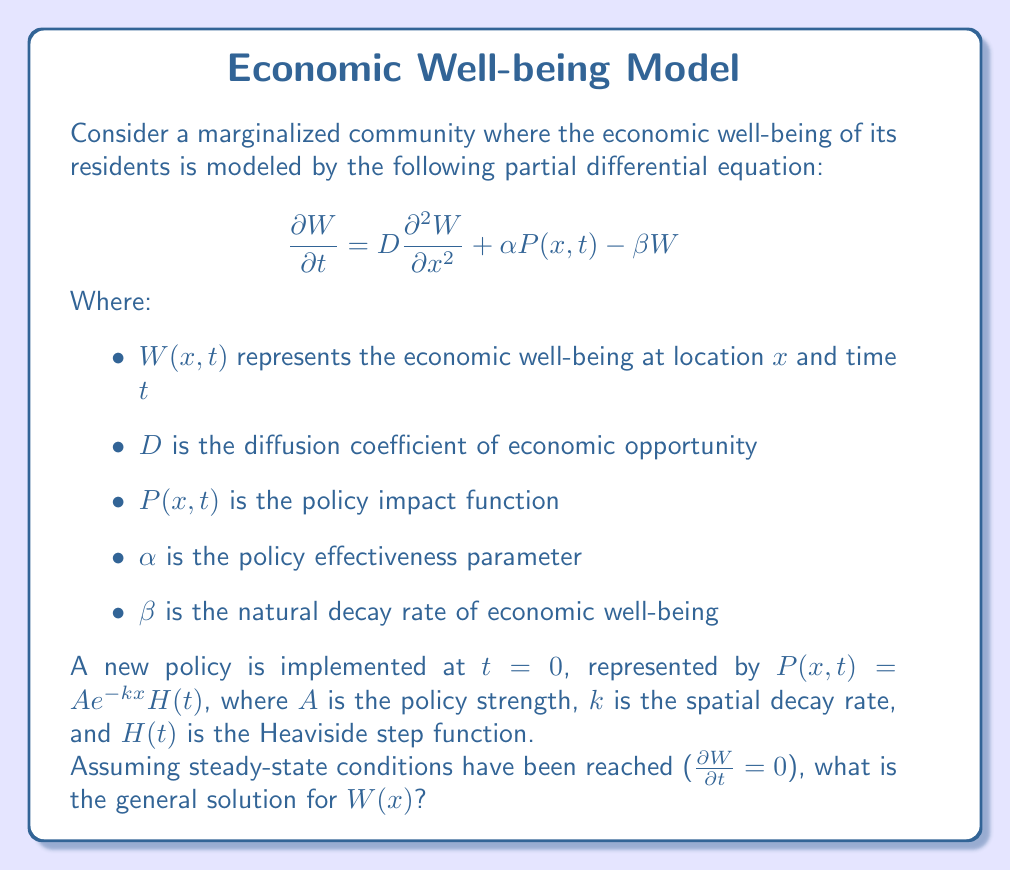Solve this math problem. To solve this problem, we'll follow these steps:

1) First, we recognize that at steady-state, $\frac{\partial W}{\partial t} = 0$. This simplifies our PDE to an ODE:

   $$D\frac{d^2 W}{dx^2} + \alpha P(x) - \beta W = 0$$

2) Substituting the given policy function $P(x) = Ae^{-kx}$, we get:

   $$D\frac{d^2 W}{dx^2} + \alpha Ae^{-kx} - \beta W = 0$$

3) This is a non-homogeneous second-order ODE. The general solution will be the sum of the homogeneous solution $W_h(x)$ and a particular solution $W_p(x)$.

4) For the homogeneous part, we solve:

   $$D\frac{d^2 W_h}{dx^2} - \beta W_h = 0$$

   The characteristic equation is $Dr^2 - \beta = 0$, giving $r = \pm \sqrt{\frac{\beta}{D}}$.

   Therefore, $W_h(x) = C_1e^{\sqrt{\frac{\beta}{D}}x} + C_2e^{-\sqrt{\frac{\beta}{D}}x}$

5) For the particular solution, we guess a form $W_p(x) = Be^{-kx}$, where $B$ is a constant to be determined.

6) Substituting this into the original ODE:

   $$D(-k)^2Be^{-kx} + \alpha Ae^{-kx} - \beta Be^{-kx} = 0$$

   $$(Dk^2 - \beta)Be^{-kx} + \alpha Ae^{-kx} = 0$$

   Solving for $B$: $B = \frac{\alpha A}{Dk^2 - \beta}$

7) The general solution is the sum of $W_h(x)$ and $W_p(x)$:

   $$W(x) = C_1e^{\sqrt{\frac{\beta}{D}}x} + C_2e^{-\sqrt{\frac{\beta}{D}}x} + \frac{\alpha A}{Dk^2 - \beta}e^{-kx}$$

This solution shows how economic well-being varies spatially in the community, reflecting both the natural diffusion of opportunity and the impact of the new policy.
Answer: $$W(x) = C_1e^{\sqrt{\frac{\beta}{D}}x} + C_2e^{-\sqrt{\frac{\beta}{D}}x} + \frac{\alpha A}{Dk^2 - \beta}e^{-kx}$$ 